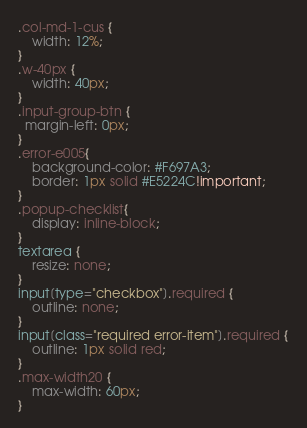Convert code to text. <code><loc_0><loc_0><loc_500><loc_500><_CSS_>.col-md-1-cus {
	width: 12%;
}
.w-40px {
	width: 40px;
}
.input-group-btn {
  margin-left: 0px;
}
.error-e005{
	background-color: #F697A3;
    border: 1px solid #E5224C!important;
}
.popup-checklist{
	display: inline-block;
}
textarea {
    resize: none;
}
input[type="checkbox"].required {
    outline: none; 
}
input[class="required error-item"].required {
    outline: 1px solid red;
}
.max-width20 {
    max-width: 60px;
}</code> 